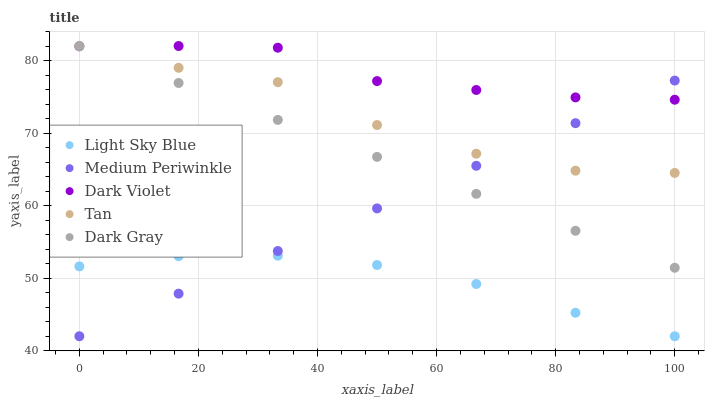Does Light Sky Blue have the minimum area under the curve?
Answer yes or no. Yes. Does Dark Violet have the maximum area under the curve?
Answer yes or no. Yes. Does Tan have the minimum area under the curve?
Answer yes or no. No. Does Tan have the maximum area under the curve?
Answer yes or no. No. Is Medium Periwinkle the smoothest?
Answer yes or no. Yes. Is Tan the roughest?
Answer yes or no. Yes. Is Light Sky Blue the smoothest?
Answer yes or no. No. Is Light Sky Blue the roughest?
Answer yes or no. No. Does Light Sky Blue have the lowest value?
Answer yes or no. Yes. Does Tan have the lowest value?
Answer yes or no. No. Does Dark Violet have the highest value?
Answer yes or no. Yes. Does Light Sky Blue have the highest value?
Answer yes or no. No. Is Light Sky Blue less than Dark Gray?
Answer yes or no. Yes. Is Dark Gray greater than Light Sky Blue?
Answer yes or no. Yes. Does Tan intersect Dark Gray?
Answer yes or no. Yes. Is Tan less than Dark Gray?
Answer yes or no. No. Is Tan greater than Dark Gray?
Answer yes or no. No. Does Light Sky Blue intersect Dark Gray?
Answer yes or no. No. 